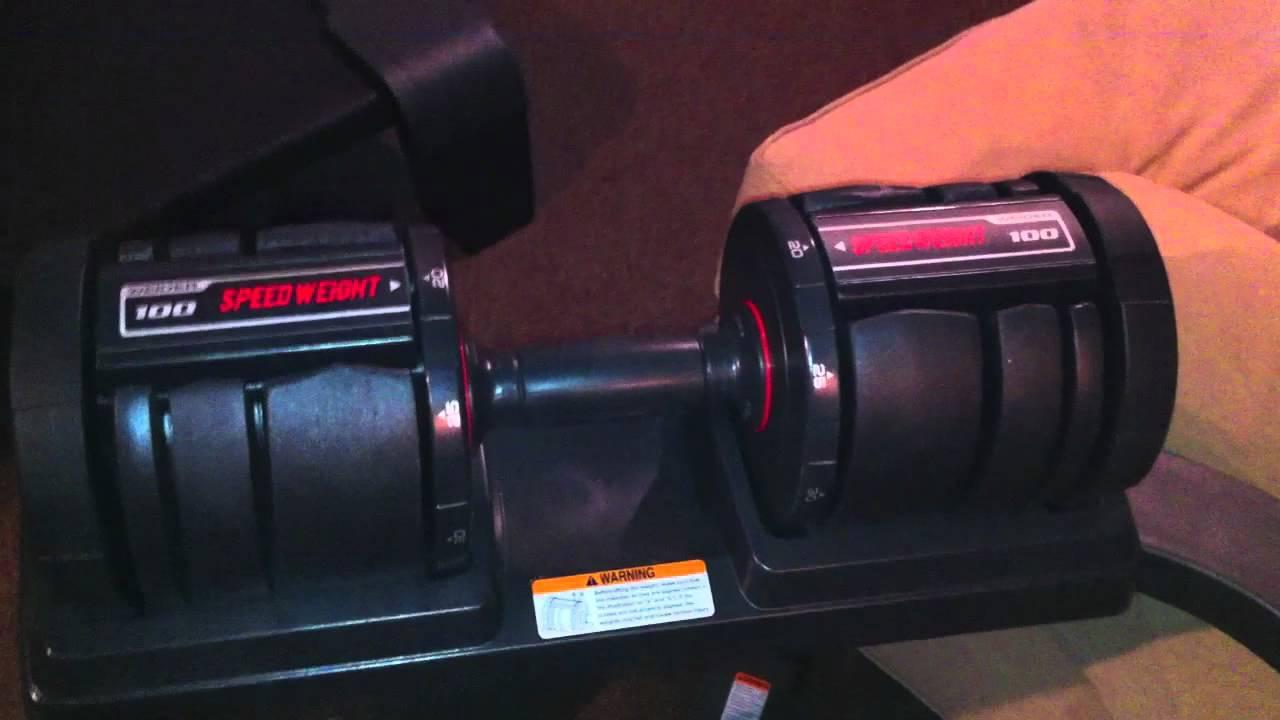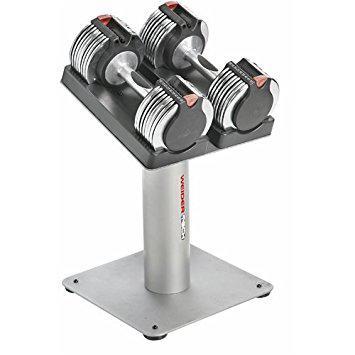The first image is the image on the left, the second image is the image on the right. Evaluate the accuracy of this statement regarding the images: "The left and right image contains the same number of weights sitting on a tower.". Is it true? Answer yes or no. No. 